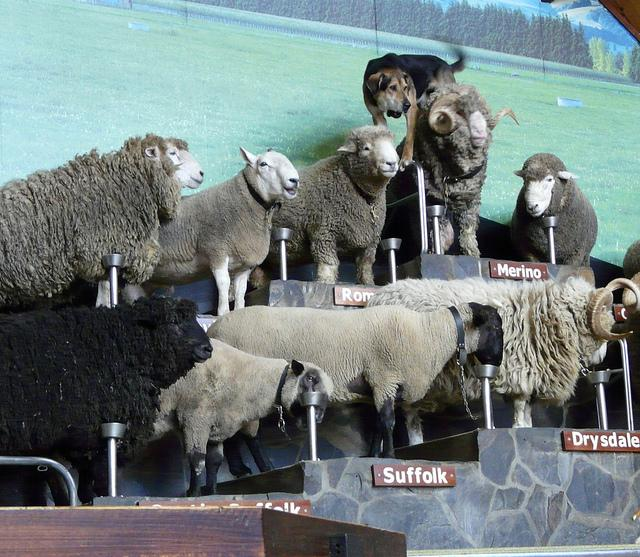Which type of sheep is the highest on the stand? merino 